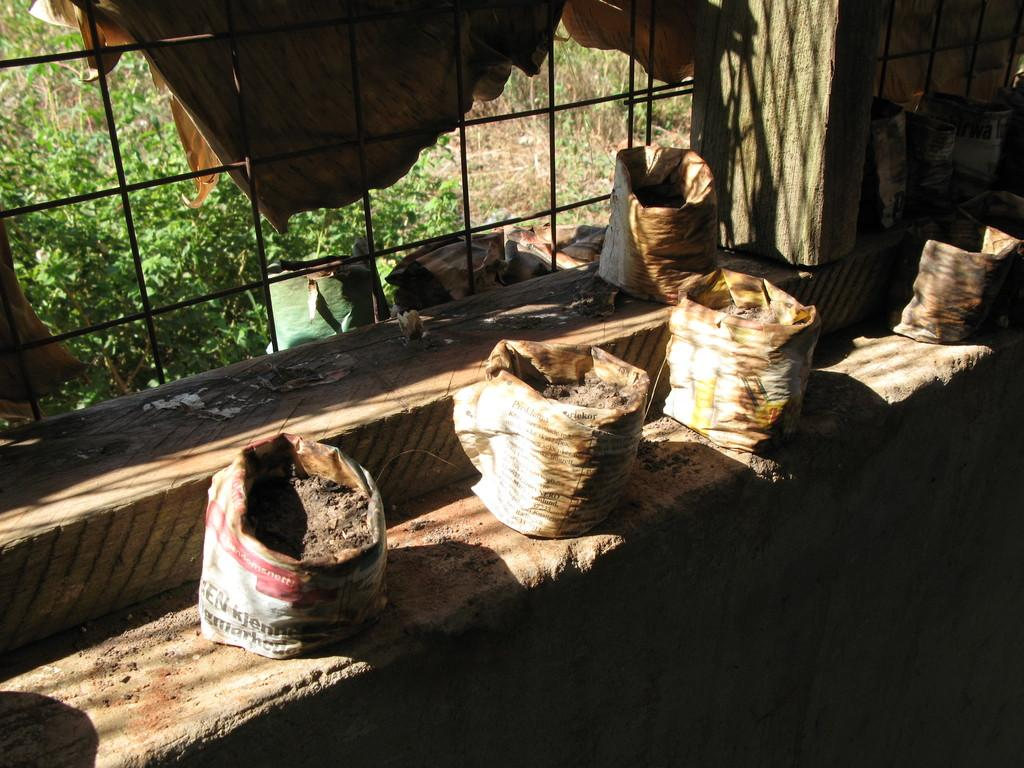What is placed on the platform in the image? There are bags with soil on the platform. What can be seen in the background of the image? There is a window in the background of the image, and plants are visible. Is there any window treatment present in the image? Yes, there is a curtain associated with the window. What type of music can be heard coming from the rabbit in the image? There is no rabbit present in the image, and therefore no music can be heard from it. 